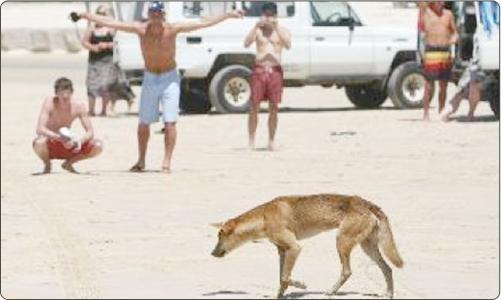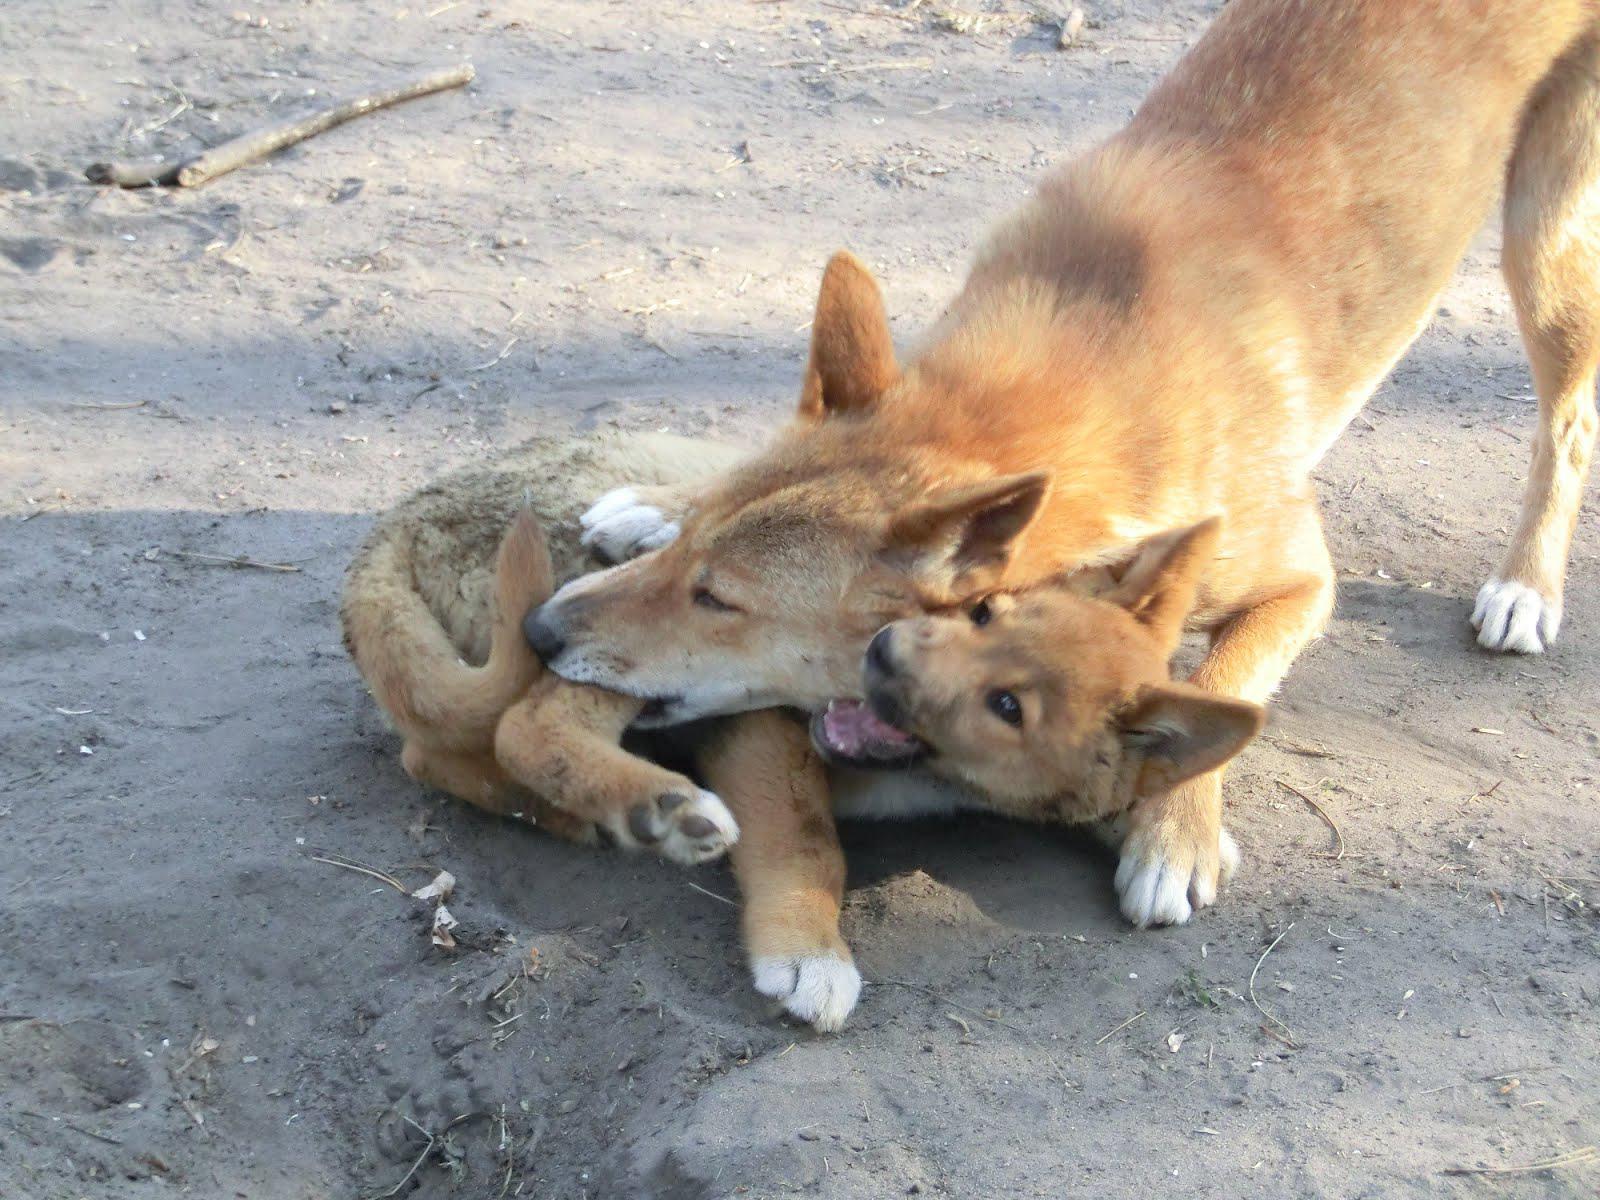The first image is the image on the left, the second image is the image on the right. Assess this claim about the two images: "One image includes a dingo moving across the sand, and the other image features an adult dingo with its head upon the body of a young dingo.". Correct or not? Answer yes or no. Yes. The first image is the image on the left, the second image is the image on the right. Evaluate the accuracy of this statement regarding the images: "The right image contains two wild dogs.". Is it true? Answer yes or no. Yes. 